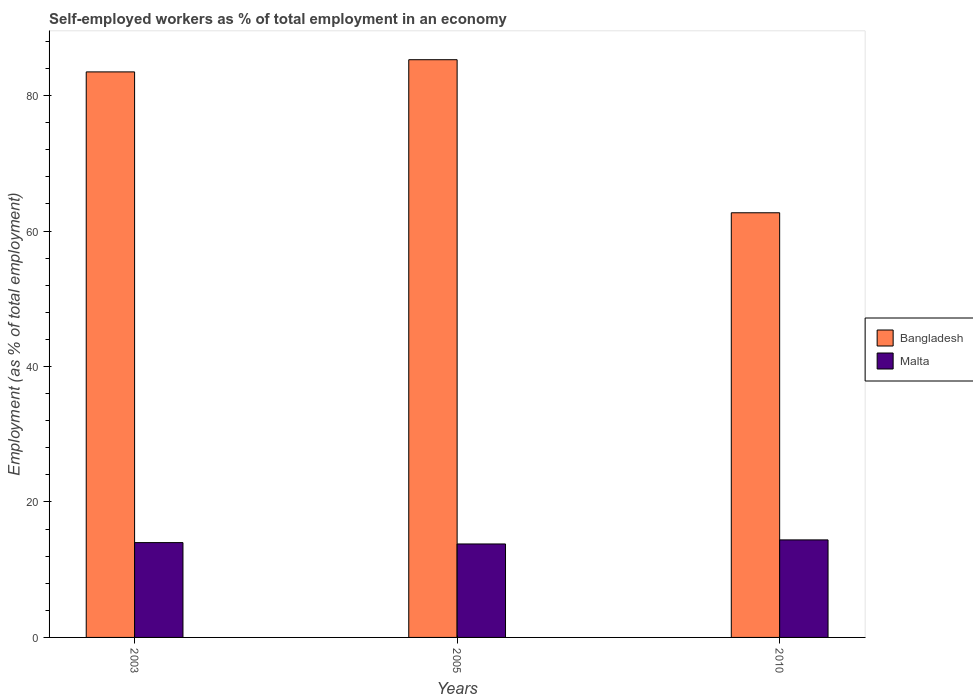How many different coloured bars are there?
Your answer should be very brief. 2. Are the number of bars per tick equal to the number of legend labels?
Offer a very short reply. Yes. How many bars are there on the 3rd tick from the left?
Provide a succinct answer. 2. In how many cases, is the number of bars for a given year not equal to the number of legend labels?
Keep it short and to the point. 0. What is the percentage of self-employed workers in Bangladesh in 2010?
Your response must be concise. 62.7. Across all years, what is the maximum percentage of self-employed workers in Bangladesh?
Your answer should be compact. 85.3. Across all years, what is the minimum percentage of self-employed workers in Malta?
Your answer should be compact. 13.8. In which year was the percentage of self-employed workers in Bangladesh maximum?
Your response must be concise. 2005. In which year was the percentage of self-employed workers in Malta minimum?
Provide a succinct answer. 2005. What is the total percentage of self-employed workers in Malta in the graph?
Offer a very short reply. 42.2. What is the difference between the percentage of self-employed workers in Bangladesh in 2003 and that in 2010?
Ensure brevity in your answer.  20.8. What is the difference between the percentage of self-employed workers in Bangladesh in 2010 and the percentage of self-employed workers in Malta in 2003?
Your response must be concise. 48.7. What is the average percentage of self-employed workers in Bangladesh per year?
Provide a short and direct response. 77.17. In the year 2003, what is the difference between the percentage of self-employed workers in Bangladesh and percentage of self-employed workers in Malta?
Keep it short and to the point. 69.5. What is the ratio of the percentage of self-employed workers in Malta in 2005 to that in 2010?
Ensure brevity in your answer.  0.96. Is the difference between the percentage of self-employed workers in Bangladesh in 2003 and 2005 greater than the difference between the percentage of self-employed workers in Malta in 2003 and 2005?
Your answer should be very brief. No. What is the difference between the highest and the second highest percentage of self-employed workers in Bangladesh?
Make the answer very short. 1.8. What is the difference between the highest and the lowest percentage of self-employed workers in Malta?
Your response must be concise. 0.6. In how many years, is the percentage of self-employed workers in Bangladesh greater than the average percentage of self-employed workers in Bangladesh taken over all years?
Provide a succinct answer. 2. What does the 2nd bar from the left in 2003 represents?
Offer a terse response. Malta. How many years are there in the graph?
Provide a succinct answer. 3. What is the difference between two consecutive major ticks on the Y-axis?
Keep it short and to the point. 20. Are the values on the major ticks of Y-axis written in scientific E-notation?
Your answer should be very brief. No. Does the graph contain any zero values?
Your response must be concise. No. How many legend labels are there?
Your answer should be compact. 2. How are the legend labels stacked?
Your response must be concise. Vertical. What is the title of the graph?
Offer a very short reply. Self-employed workers as % of total employment in an economy. What is the label or title of the X-axis?
Ensure brevity in your answer.  Years. What is the label or title of the Y-axis?
Keep it short and to the point. Employment (as % of total employment). What is the Employment (as % of total employment) in Bangladesh in 2003?
Make the answer very short. 83.5. What is the Employment (as % of total employment) in Bangladesh in 2005?
Give a very brief answer. 85.3. What is the Employment (as % of total employment) in Malta in 2005?
Provide a succinct answer. 13.8. What is the Employment (as % of total employment) in Bangladesh in 2010?
Keep it short and to the point. 62.7. What is the Employment (as % of total employment) in Malta in 2010?
Offer a very short reply. 14.4. Across all years, what is the maximum Employment (as % of total employment) of Bangladesh?
Ensure brevity in your answer.  85.3. Across all years, what is the maximum Employment (as % of total employment) of Malta?
Give a very brief answer. 14.4. Across all years, what is the minimum Employment (as % of total employment) of Bangladesh?
Provide a succinct answer. 62.7. Across all years, what is the minimum Employment (as % of total employment) of Malta?
Make the answer very short. 13.8. What is the total Employment (as % of total employment) in Bangladesh in the graph?
Your answer should be very brief. 231.5. What is the total Employment (as % of total employment) of Malta in the graph?
Ensure brevity in your answer.  42.2. What is the difference between the Employment (as % of total employment) in Bangladesh in 2003 and that in 2005?
Your response must be concise. -1.8. What is the difference between the Employment (as % of total employment) in Malta in 2003 and that in 2005?
Your answer should be very brief. 0.2. What is the difference between the Employment (as % of total employment) in Bangladesh in 2003 and that in 2010?
Your response must be concise. 20.8. What is the difference between the Employment (as % of total employment) in Malta in 2003 and that in 2010?
Offer a very short reply. -0.4. What is the difference between the Employment (as % of total employment) of Bangladesh in 2005 and that in 2010?
Offer a very short reply. 22.6. What is the difference between the Employment (as % of total employment) in Bangladesh in 2003 and the Employment (as % of total employment) in Malta in 2005?
Provide a short and direct response. 69.7. What is the difference between the Employment (as % of total employment) in Bangladesh in 2003 and the Employment (as % of total employment) in Malta in 2010?
Offer a terse response. 69.1. What is the difference between the Employment (as % of total employment) in Bangladesh in 2005 and the Employment (as % of total employment) in Malta in 2010?
Keep it short and to the point. 70.9. What is the average Employment (as % of total employment) of Bangladesh per year?
Offer a very short reply. 77.17. What is the average Employment (as % of total employment) of Malta per year?
Keep it short and to the point. 14.07. In the year 2003, what is the difference between the Employment (as % of total employment) of Bangladesh and Employment (as % of total employment) of Malta?
Make the answer very short. 69.5. In the year 2005, what is the difference between the Employment (as % of total employment) of Bangladesh and Employment (as % of total employment) of Malta?
Keep it short and to the point. 71.5. In the year 2010, what is the difference between the Employment (as % of total employment) of Bangladesh and Employment (as % of total employment) of Malta?
Your response must be concise. 48.3. What is the ratio of the Employment (as % of total employment) of Bangladesh in 2003 to that in 2005?
Make the answer very short. 0.98. What is the ratio of the Employment (as % of total employment) of Malta in 2003 to that in 2005?
Provide a short and direct response. 1.01. What is the ratio of the Employment (as % of total employment) in Bangladesh in 2003 to that in 2010?
Give a very brief answer. 1.33. What is the ratio of the Employment (as % of total employment) in Malta in 2003 to that in 2010?
Provide a short and direct response. 0.97. What is the ratio of the Employment (as % of total employment) of Bangladesh in 2005 to that in 2010?
Give a very brief answer. 1.36. What is the ratio of the Employment (as % of total employment) in Malta in 2005 to that in 2010?
Your answer should be very brief. 0.96. What is the difference between the highest and the second highest Employment (as % of total employment) of Malta?
Keep it short and to the point. 0.4. What is the difference between the highest and the lowest Employment (as % of total employment) of Bangladesh?
Offer a terse response. 22.6. 